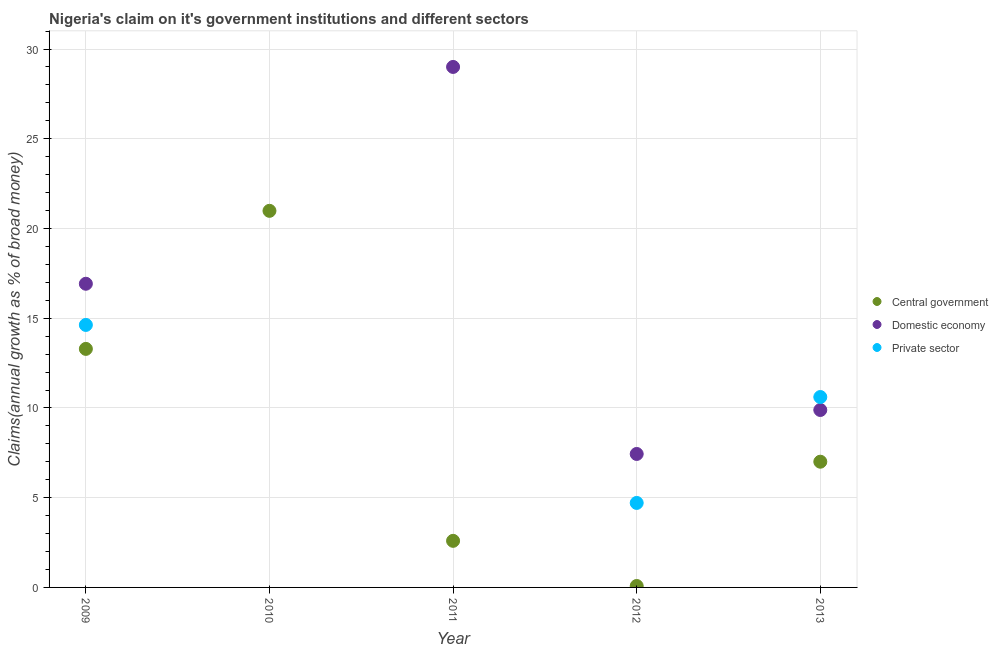How many different coloured dotlines are there?
Offer a terse response. 3. Is the number of dotlines equal to the number of legend labels?
Your answer should be very brief. No. What is the percentage of claim on the private sector in 2009?
Offer a very short reply. 14.63. Across all years, what is the maximum percentage of claim on the private sector?
Your answer should be compact. 14.63. Across all years, what is the minimum percentage of claim on the private sector?
Give a very brief answer. 0. What is the total percentage of claim on the private sector in the graph?
Offer a terse response. 29.94. What is the difference between the percentage of claim on the central government in 2009 and that in 2011?
Keep it short and to the point. 10.7. What is the difference between the percentage of claim on the domestic economy in 2010 and the percentage of claim on the central government in 2013?
Keep it short and to the point. -7.01. What is the average percentage of claim on the domestic economy per year?
Provide a succinct answer. 12.65. In the year 2012, what is the difference between the percentage of claim on the central government and percentage of claim on the domestic economy?
Your answer should be compact. -7.36. In how many years, is the percentage of claim on the domestic economy greater than 16 %?
Your answer should be very brief. 2. What is the ratio of the percentage of claim on the domestic economy in 2012 to that in 2013?
Provide a short and direct response. 0.75. Is the difference between the percentage of claim on the central government in 2009 and 2012 greater than the difference between the percentage of claim on the domestic economy in 2009 and 2012?
Provide a short and direct response. Yes. What is the difference between the highest and the second highest percentage of claim on the central government?
Make the answer very short. 7.69. What is the difference between the highest and the lowest percentage of claim on the central government?
Provide a succinct answer. 20.9. In how many years, is the percentage of claim on the private sector greater than the average percentage of claim on the private sector taken over all years?
Give a very brief answer. 2. Is the sum of the percentage of claim on the domestic economy in 2009 and 2012 greater than the maximum percentage of claim on the central government across all years?
Give a very brief answer. Yes. Does the percentage of claim on the domestic economy monotonically increase over the years?
Your answer should be very brief. No. Is the percentage of claim on the domestic economy strictly greater than the percentage of claim on the central government over the years?
Your response must be concise. No. Does the graph contain any zero values?
Provide a succinct answer. Yes. Does the graph contain grids?
Give a very brief answer. Yes. Where does the legend appear in the graph?
Ensure brevity in your answer.  Center right. What is the title of the graph?
Provide a short and direct response. Nigeria's claim on it's government institutions and different sectors. What is the label or title of the X-axis?
Offer a very short reply. Year. What is the label or title of the Y-axis?
Keep it short and to the point. Claims(annual growth as % of broad money). What is the Claims(annual growth as % of broad money) in Central government in 2009?
Provide a short and direct response. 13.29. What is the Claims(annual growth as % of broad money) of Domestic economy in 2009?
Ensure brevity in your answer.  16.92. What is the Claims(annual growth as % of broad money) in Private sector in 2009?
Provide a short and direct response. 14.63. What is the Claims(annual growth as % of broad money) in Central government in 2010?
Keep it short and to the point. 20.98. What is the Claims(annual growth as % of broad money) in Central government in 2011?
Make the answer very short. 2.6. What is the Claims(annual growth as % of broad money) in Domestic economy in 2011?
Make the answer very short. 29. What is the Claims(annual growth as % of broad money) in Private sector in 2011?
Your answer should be compact. 0. What is the Claims(annual growth as % of broad money) in Central government in 2012?
Provide a succinct answer. 0.08. What is the Claims(annual growth as % of broad money) of Domestic economy in 2012?
Your answer should be very brief. 7.44. What is the Claims(annual growth as % of broad money) of Private sector in 2012?
Give a very brief answer. 4.71. What is the Claims(annual growth as % of broad money) in Central government in 2013?
Your answer should be compact. 7.01. What is the Claims(annual growth as % of broad money) in Domestic economy in 2013?
Your answer should be compact. 9.89. What is the Claims(annual growth as % of broad money) of Private sector in 2013?
Your response must be concise. 10.61. Across all years, what is the maximum Claims(annual growth as % of broad money) of Central government?
Your answer should be very brief. 20.98. Across all years, what is the maximum Claims(annual growth as % of broad money) in Domestic economy?
Ensure brevity in your answer.  29. Across all years, what is the maximum Claims(annual growth as % of broad money) in Private sector?
Give a very brief answer. 14.63. Across all years, what is the minimum Claims(annual growth as % of broad money) of Central government?
Offer a terse response. 0.08. Across all years, what is the minimum Claims(annual growth as % of broad money) of Domestic economy?
Make the answer very short. 0. Across all years, what is the minimum Claims(annual growth as % of broad money) in Private sector?
Provide a short and direct response. 0. What is the total Claims(annual growth as % of broad money) in Central government in the graph?
Offer a terse response. 43.96. What is the total Claims(annual growth as % of broad money) in Domestic economy in the graph?
Give a very brief answer. 63.25. What is the total Claims(annual growth as % of broad money) in Private sector in the graph?
Provide a short and direct response. 29.94. What is the difference between the Claims(annual growth as % of broad money) of Central government in 2009 and that in 2010?
Your answer should be very brief. -7.69. What is the difference between the Claims(annual growth as % of broad money) of Central government in 2009 and that in 2011?
Make the answer very short. 10.7. What is the difference between the Claims(annual growth as % of broad money) in Domestic economy in 2009 and that in 2011?
Your answer should be compact. -12.08. What is the difference between the Claims(annual growth as % of broad money) in Central government in 2009 and that in 2012?
Ensure brevity in your answer.  13.21. What is the difference between the Claims(annual growth as % of broad money) in Domestic economy in 2009 and that in 2012?
Offer a terse response. 9.48. What is the difference between the Claims(annual growth as % of broad money) of Private sector in 2009 and that in 2012?
Provide a short and direct response. 9.92. What is the difference between the Claims(annual growth as % of broad money) of Central government in 2009 and that in 2013?
Ensure brevity in your answer.  6.29. What is the difference between the Claims(annual growth as % of broad money) of Domestic economy in 2009 and that in 2013?
Provide a short and direct response. 7.03. What is the difference between the Claims(annual growth as % of broad money) of Private sector in 2009 and that in 2013?
Offer a terse response. 4.02. What is the difference between the Claims(annual growth as % of broad money) in Central government in 2010 and that in 2011?
Keep it short and to the point. 18.39. What is the difference between the Claims(annual growth as % of broad money) in Central government in 2010 and that in 2012?
Make the answer very short. 20.9. What is the difference between the Claims(annual growth as % of broad money) of Central government in 2010 and that in 2013?
Keep it short and to the point. 13.98. What is the difference between the Claims(annual growth as % of broad money) of Central government in 2011 and that in 2012?
Ensure brevity in your answer.  2.52. What is the difference between the Claims(annual growth as % of broad money) in Domestic economy in 2011 and that in 2012?
Offer a very short reply. 21.57. What is the difference between the Claims(annual growth as % of broad money) of Central government in 2011 and that in 2013?
Your answer should be very brief. -4.41. What is the difference between the Claims(annual growth as % of broad money) in Domestic economy in 2011 and that in 2013?
Your answer should be compact. 19.12. What is the difference between the Claims(annual growth as % of broad money) in Central government in 2012 and that in 2013?
Give a very brief answer. -6.93. What is the difference between the Claims(annual growth as % of broad money) in Domestic economy in 2012 and that in 2013?
Your response must be concise. -2.45. What is the difference between the Claims(annual growth as % of broad money) in Private sector in 2012 and that in 2013?
Make the answer very short. -5.9. What is the difference between the Claims(annual growth as % of broad money) of Central government in 2009 and the Claims(annual growth as % of broad money) of Domestic economy in 2011?
Your response must be concise. -15.71. What is the difference between the Claims(annual growth as % of broad money) of Central government in 2009 and the Claims(annual growth as % of broad money) of Domestic economy in 2012?
Your answer should be very brief. 5.85. What is the difference between the Claims(annual growth as % of broad money) of Central government in 2009 and the Claims(annual growth as % of broad money) of Private sector in 2012?
Give a very brief answer. 8.58. What is the difference between the Claims(annual growth as % of broad money) in Domestic economy in 2009 and the Claims(annual growth as % of broad money) in Private sector in 2012?
Offer a terse response. 12.21. What is the difference between the Claims(annual growth as % of broad money) in Central government in 2009 and the Claims(annual growth as % of broad money) in Domestic economy in 2013?
Provide a succinct answer. 3.4. What is the difference between the Claims(annual growth as % of broad money) in Central government in 2009 and the Claims(annual growth as % of broad money) in Private sector in 2013?
Provide a short and direct response. 2.68. What is the difference between the Claims(annual growth as % of broad money) in Domestic economy in 2009 and the Claims(annual growth as % of broad money) in Private sector in 2013?
Ensure brevity in your answer.  6.31. What is the difference between the Claims(annual growth as % of broad money) in Central government in 2010 and the Claims(annual growth as % of broad money) in Domestic economy in 2011?
Give a very brief answer. -8.02. What is the difference between the Claims(annual growth as % of broad money) of Central government in 2010 and the Claims(annual growth as % of broad money) of Domestic economy in 2012?
Give a very brief answer. 13.55. What is the difference between the Claims(annual growth as % of broad money) in Central government in 2010 and the Claims(annual growth as % of broad money) in Private sector in 2012?
Your answer should be very brief. 16.28. What is the difference between the Claims(annual growth as % of broad money) in Central government in 2010 and the Claims(annual growth as % of broad money) in Domestic economy in 2013?
Your answer should be very brief. 11.1. What is the difference between the Claims(annual growth as % of broad money) of Central government in 2010 and the Claims(annual growth as % of broad money) of Private sector in 2013?
Provide a succinct answer. 10.37. What is the difference between the Claims(annual growth as % of broad money) of Central government in 2011 and the Claims(annual growth as % of broad money) of Domestic economy in 2012?
Provide a short and direct response. -4.84. What is the difference between the Claims(annual growth as % of broad money) in Central government in 2011 and the Claims(annual growth as % of broad money) in Private sector in 2012?
Keep it short and to the point. -2.11. What is the difference between the Claims(annual growth as % of broad money) in Domestic economy in 2011 and the Claims(annual growth as % of broad money) in Private sector in 2012?
Make the answer very short. 24.29. What is the difference between the Claims(annual growth as % of broad money) in Central government in 2011 and the Claims(annual growth as % of broad money) in Domestic economy in 2013?
Provide a short and direct response. -7.29. What is the difference between the Claims(annual growth as % of broad money) in Central government in 2011 and the Claims(annual growth as % of broad money) in Private sector in 2013?
Provide a succinct answer. -8.01. What is the difference between the Claims(annual growth as % of broad money) of Domestic economy in 2011 and the Claims(annual growth as % of broad money) of Private sector in 2013?
Provide a succinct answer. 18.39. What is the difference between the Claims(annual growth as % of broad money) in Central government in 2012 and the Claims(annual growth as % of broad money) in Domestic economy in 2013?
Keep it short and to the point. -9.81. What is the difference between the Claims(annual growth as % of broad money) in Central government in 2012 and the Claims(annual growth as % of broad money) in Private sector in 2013?
Make the answer very short. -10.53. What is the difference between the Claims(annual growth as % of broad money) of Domestic economy in 2012 and the Claims(annual growth as % of broad money) of Private sector in 2013?
Make the answer very short. -3.17. What is the average Claims(annual growth as % of broad money) of Central government per year?
Ensure brevity in your answer.  8.79. What is the average Claims(annual growth as % of broad money) in Domestic economy per year?
Provide a short and direct response. 12.65. What is the average Claims(annual growth as % of broad money) of Private sector per year?
Make the answer very short. 5.99. In the year 2009, what is the difference between the Claims(annual growth as % of broad money) of Central government and Claims(annual growth as % of broad money) of Domestic economy?
Provide a short and direct response. -3.63. In the year 2009, what is the difference between the Claims(annual growth as % of broad money) in Central government and Claims(annual growth as % of broad money) in Private sector?
Your answer should be very brief. -1.33. In the year 2009, what is the difference between the Claims(annual growth as % of broad money) of Domestic economy and Claims(annual growth as % of broad money) of Private sector?
Your answer should be compact. 2.29. In the year 2011, what is the difference between the Claims(annual growth as % of broad money) of Central government and Claims(annual growth as % of broad money) of Domestic economy?
Give a very brief answer. -26.41. In the year 2012, what is the difference between the Claims(annual growth as % of broad money) of Central government and Claims(annual growth as % of broad money) of Domestic economy?
Provide a short and direct response. -7.36. In the year 2012, what is the difference between the Claims(annual growth as % of broad money) in Central government and Claims(annual growth as % of broad money) in Private sector?
Your answer should be very brief. -4.63. In the year 2012, what is the difference between the Claims(annual growth as % of broad money) of Domestic economy and Claims(annual growth as % of broad money) of Private sector?
Your answer should be very brief. 2.73. In the year 2013, what is the difference between the Claims(annual growth as % of broad money) of Central government and Claims(annual growth as % of broad money) of Domestic economy?
Provide a short and direct response. -2.88. In the year 2013, what is the difference between the Claims(annual growth as % of broad money) in Central government and Claims(annual growth as % of broad money) in Private sector?
Provide a succinct answer. -3.6. In the year 2013, what is the difference between the Claims(annual growth as % of broad money) in Domestic economy and Claims(annual growth as % of broad money) in Private sector?
Your answer should be compact. -0.72. What is the ratio of the Claims(annual growth as % of broad money) in Central government in 2009 to that in 2010?
Offer a very short reply. 0.63. What is the ratio of the Claims(annual growth as % of broad money) in Central government in 2009 to that in 2011?
Give a very brief answer. 5.12. What is the ratio of the Claims(annual growth as % of broad money) in Domestic economy in 2009 to that in 2011?
Your response must be concise. 0.58. What is the ratio of the Claims(annual growth as % of broad money) of Central government in 2009 to that in 2012?
Your answer should be compact. 166.89. What is the ratio of the Claims(annual growth as % of broad money) in Domestic economy in 2009 to that in 2012?
Offer a terse response. 2.28. What is the ratio of the Claims(annual growth as % of broad money) of Private sector in 2009 to that in 2012?
Provide a succinct answer. 3.11. What is the ratio of the Claims(annual growth as % of broad money) of Central government in 2009 to that in 2013?
Make the answer very short. 1.9. What is the ratio of the Claims(annual growth as % of broad money) in Domestic economy in 2009 to that in 2013?
Provide a succinct answer. 1.71. What is the ratio of the Claims(annual growth as % of broad money) in Private sector in 2009 to that in 2013?
Your response must be concise. 1.38. What is the ratio of the Claims(annual growth as % of broad money) in Central government in 2010 to that in 2011?
Your response must be concise. 8.08. What is the ratio of the Claims(annual growth as % of broad money) of Central government in 2010 to that in 2012?
Provide a succinct answer. 263.48. What is the ratio of the Claims(annual growth as % of broad money) of Central government in 2010 to that in 2013?
Your answer should be very brief. 3. What is the ratio of the Claims(annual growth as % of broad money) in Central government in 2011 to that in 2012?
Offer a very short reply. 32.59. What is the ratio of the Claims(annual growth as % of broad money) in Domestic economy in 2011 to that in 2012?
Your answer should be very brief. 3.9. What is the ratio of the Claims(annual growth as % of broad money) in Central government in 2011 to that in 2013?
Make the answer very short. 0.37. What is the ratio of the Claims(annual growth as % of broad money) of Domestic economy in 2011 to that in 2013?
Your answer should be very brief. 2.93. What is the ratio of the Claims(annual growth as % of broad money) of Central government in 2012 to that in 2013?
Keep it short and to the point. 0.01. What is the ratio of the Claims(annual growth as % of broad money) in Domestic economy in 2012 to that in 2013?
Provide a short and direct response. 0.75. What is the ratio of the Claims(annual growth as % of broad money) of Private sector in 2012 to that in 2013?
Offer a terse response. 0.44. What is the difference between the highest and the second highest Claims(annual growth as % of broad money) of Central government?
Provide a succinct answer. 7.69. What is the difference between the highest and the second highest Claims(annual growth as % of broad money) of Domestic economy?
Give a very brief answer. 12.08. What is the difference between the highest and the second highest Claims(annual growth as % of broad money) in Private sector?
Keep it short and to the point. 4.02. What is the difference between the highest and the lowest Claims(annual growth as % of broad money) in Central government?
Offer a very short reply. 20.9. What is the difference between the highest and the lowest Claims(annual growth as % of broad money) in Domestic economy?
Give a very brief answer. 29. What is the difference between the highest and the lowest Claims(annual growth as % of broad money) in Private sector?
Offer a very short reply. 14.63. 